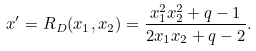<formula> <loc_0><loc_0><loc_500><loc_500>x ^ { \prime } = { R } _ { D } ( x _ { 1 } , x _ { 2 } ) = \frac { x _ { 1 } ^ { 2 } x _ { 2 } ^ { 2 } + q - 1 } { 2 x _ { 1 } x _ { 2 } + q - 2 } .</formula> 